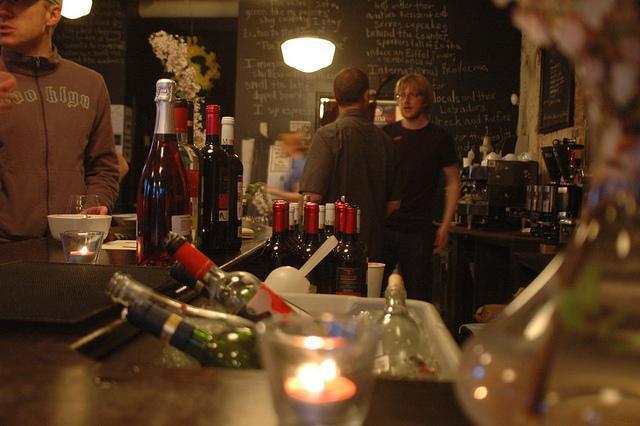How many bottles can you see?
Give a very brief answer. 7. How many people can be seen?
Give a very brief answer. 3. 